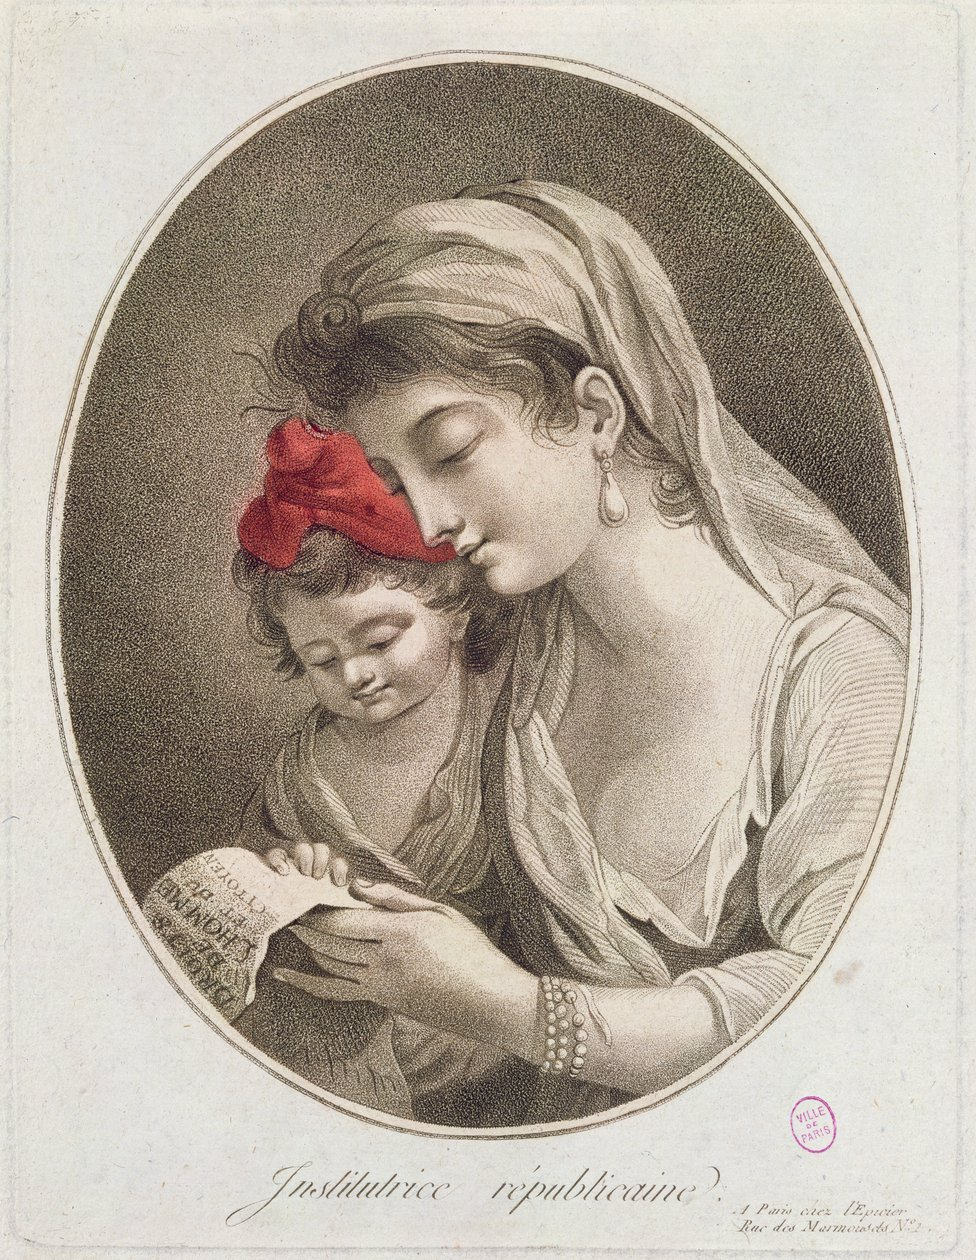Describe This image is a historical engraving or print titled "Institutrice républicaine" (Republican Teacher) at the bottom. It depicts a tender scene of education and maternal care.

The oval-framed illustration shows two figures - an older woman and a young child. The woman, presumably the teacher, is wearing a light-colored dress and a head covering or veil. She has her eyes closed and is leaning towards the child in a protective, nurturing pose.

The child, who appears to be a young girl, is wearing a red bow or cap on her head, which stands out as the only colored element in the otherwise monochrome image. The child is holding what looks like a document or book, and both figures seem to be studying or reading it together.

The woman is adorned with simple jewelry - an earring and a pearl bracelet are visible. The overall style and clothing suggest this is from the late 18th or early 19th century.

The image conveys a sense of gentle guidance and the importance of education, particularly in the context of republican ideals as suggested by the title. It's a beautifully rendered piece that captures a moment of quiet instruction and care. 